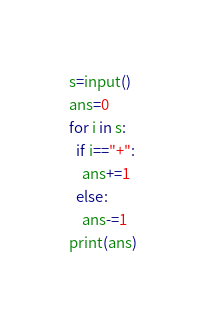<code> <loc_0><loc_0><loc_500><loc_500><_C#_>s=input()
ans=0
for i in s:
  if i=="+":
    ans+=1
  else:
    ans-=1
print(ans)</code> 